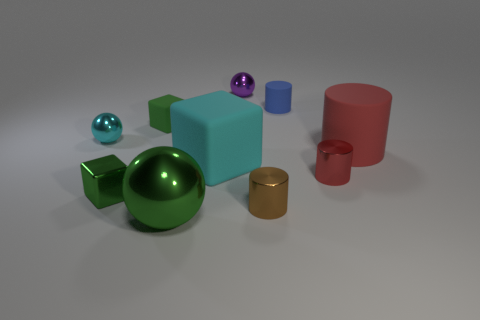Subtract all cyan cubes. How many cubes are left? 2 Subtract all blue cylinders. How many cylinders are left? 3 Subtract all cyan spheres. How many gray cylinders are left? 0 Subtract all small cyan metal balls. Subtract all big cyan objects. How many objects are left? 8 Add 5 red shiny cylinders. How many red shiny cylinders are left? 6 Add 3 small shiny objects. How many small shiny objects exist? 8 Subtract 0 yellow cubes. How many objects are left? 10 Subtract all cylinders. How many objects are left? 6 Subtract 2 cylinders. How many cylinders are left? 2 Subtract all purple spheres. Subtract all red cylinders. How many spheres are left? 2 